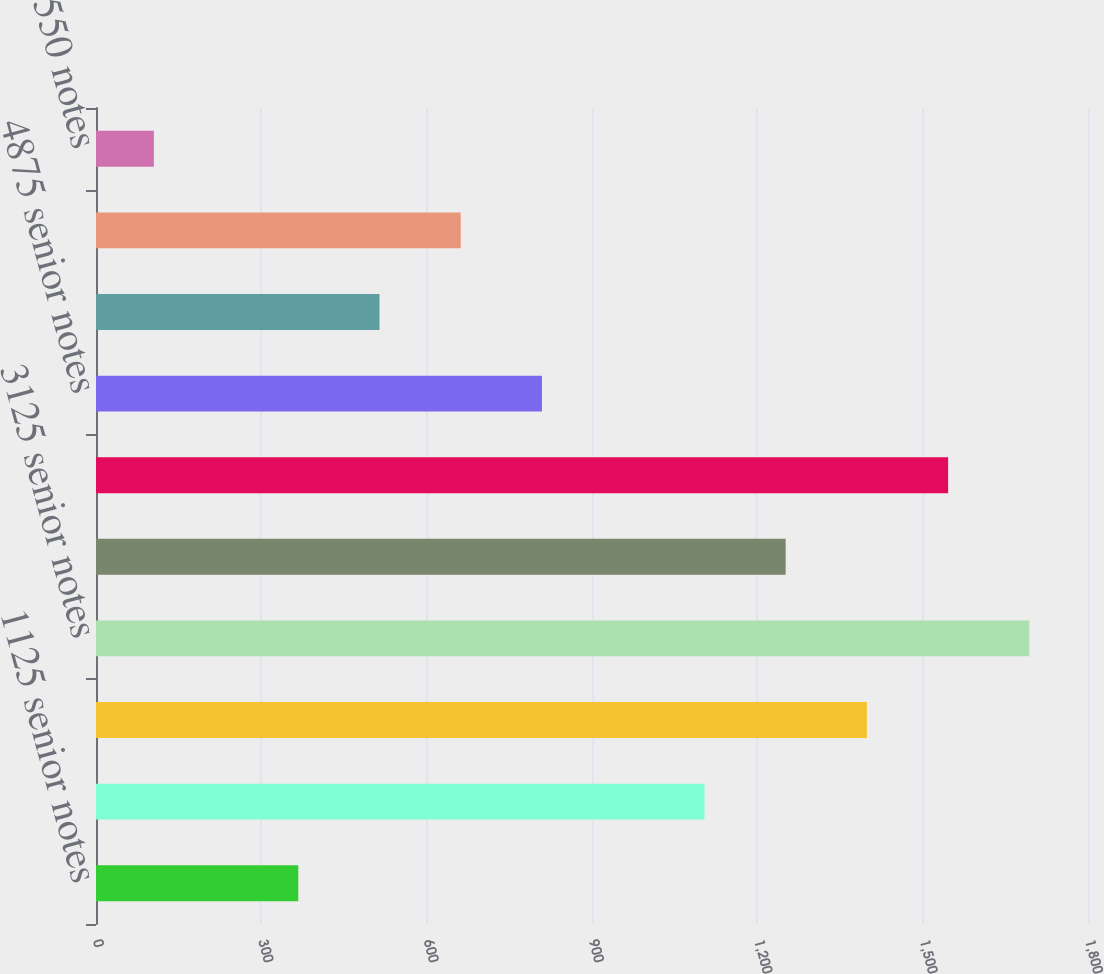<chart> <loc_0><loc_0><loc_500><loc_500><bar_chart><fcel>1125 senior notes<fcel>550 senior notes<fcel>5125 senior notes<fcel>3125 senior notes<fcel>245 senior notes<fcel>620 senior notes<fcel>4875 senior notes<fcel>3625 senior notes<fcel>8375 debentures<fcel>550 notes<nl><fcel>367<fcel>1104<fcel>1398.8<fcel>1693.6<fcel>1251.4<fcel>1546.2<fcel>809.2<fcel>514.4<fcel>661.8<fcel>105<nl></chart> 